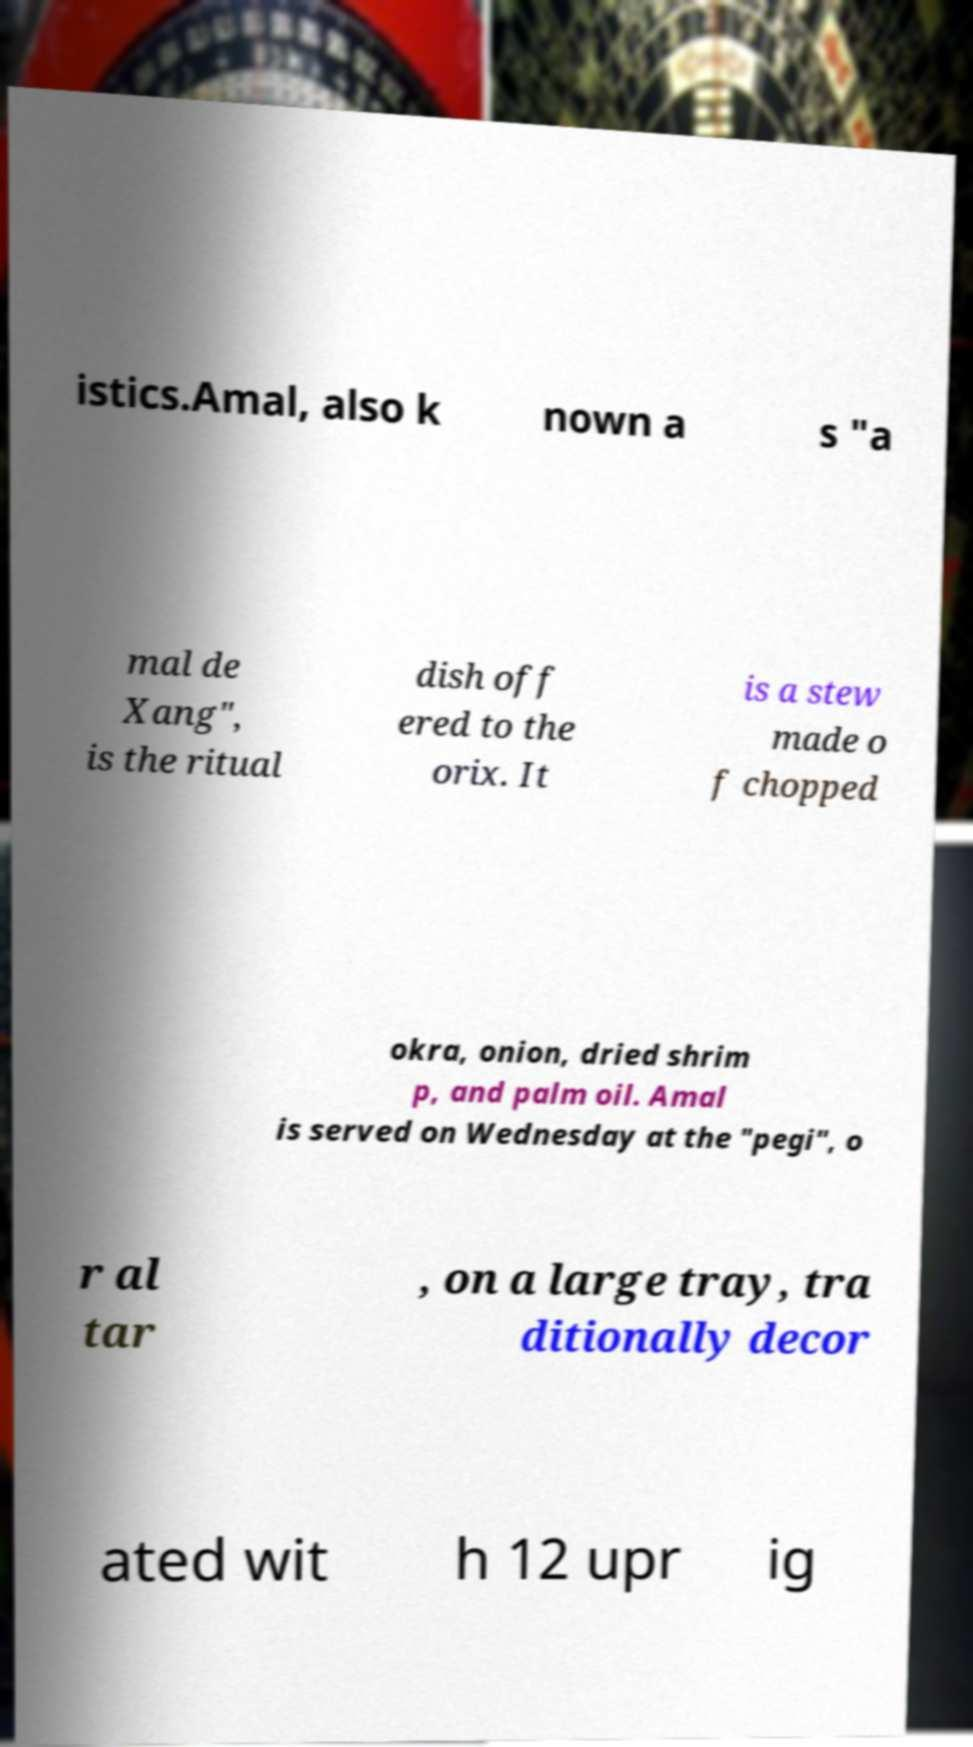Can you accurately transcribe the text from the provided image for me? istics.Amal, also k nown a s "a mal de Xang", is the ritual dish off ered to the orix. It is a stew made o f chopped okra, onion, dried shrim p, and palm oil. Amal is served on Wednesday at the "pegi", o r al tar , on a large tray, tra ditionally decor ated wit h 12 upr ig 